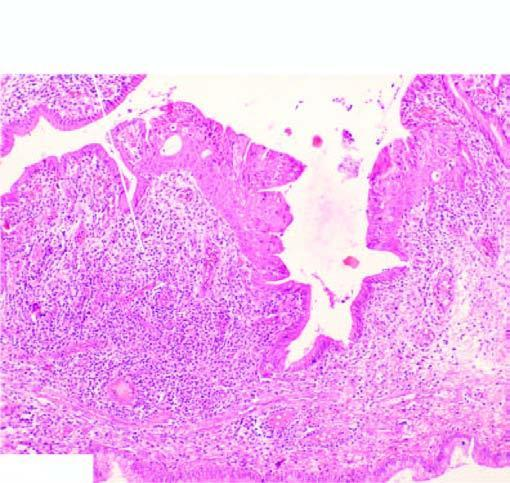where are foci of metaplastic squamous epithelium seen?
Answer the question using a single word or phrase. At other places 